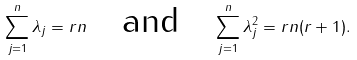<formula> <loc_0><loc_0><loc_500><loc_500>\sum _ { j = 1 } ^ { n } \lambda _ { j } = r n \quad \text {and} \quad \sum _ { j = 1 } ^ { n } \lambda _ { j } ^ { 2 } = r n ( r + 1 ) .</formula> 